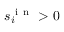Convert formula to latex. <formula><loc_0><loc_0><loc_500><loc_500>s _ { i } ^ { i n } > 0</formula> 